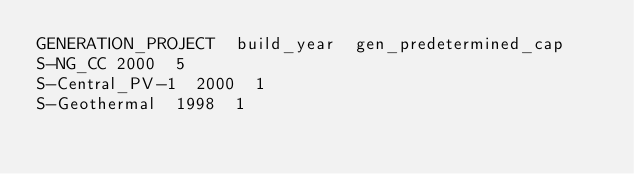<code> <loc_0><loc_0><loc_500><loc_500><_SQL_>GENERATION_PROJECT	build_year	gen_predetermined_cap
S-NG_CC	2000	5
S-Central_PV-1	2000	1
S-Geothermal	1998	1
</code> 